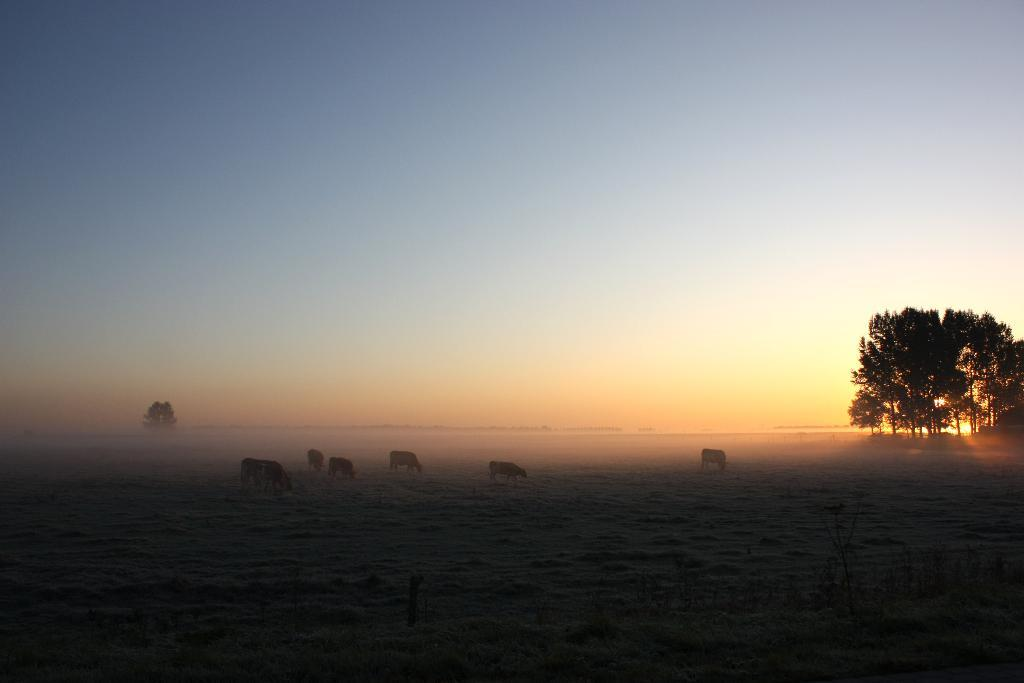What type of living organisms are on the ground in the image? There are animals on the ground in the image. What type of vegetation can be seen in the image? There are trees visible in the image. What part of the natural environment is visible in the image? The sky is visible in the image. What type of food can be seen in the downtown area of the image? There is no mention of food or a downtown area in the image, as it features animals on the ground, trees, and the sky. 